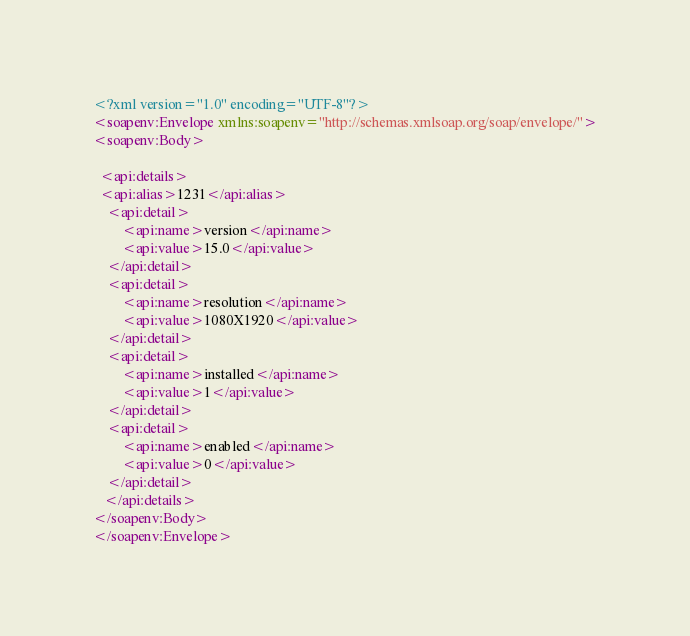Convert code to text. <code><loc_0><loc_0><loc_500><loc_500><_XML_><?xml version="1.0" encoding="UTF-8"?>
<soapenv:Envelope xmlns:soapenv="http://schemas.xmlsoap.org/soap/envelope/">
<soapenv:Body>
  
  <api:details>
  <api:alias>1231</api:alias>
    <api:detail>
        <api:name>version</api:name>
        <api:value>15.0</api:value>
    </api:detail>
    <api:detail>
        <api:name>resolution</api:name>
        <api:value>1080X1920</api:value>
    </api:detail>
    <api:detail>
        <api:name>installed</api:name>
        <api:value>1</api:value>
    </api:detail>
    <api:detail>
        <api:name>enabled</api:name>
        <api:value>0</api:value>
    </api:detail>
   </api:details>
</soapenv:Body>
</soapenv:Envelope>
</code> 